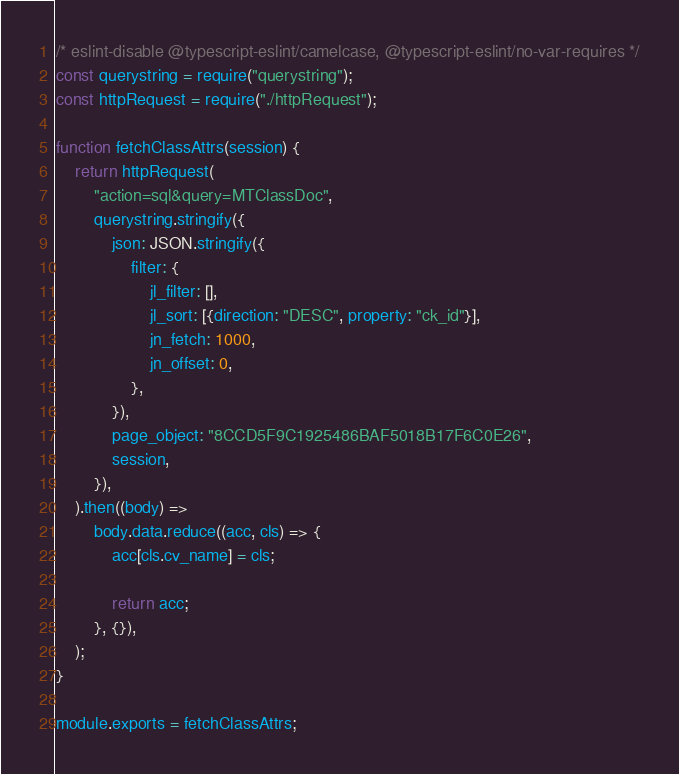Convert code to text. <code><loc_0><loc_0><loc_500><loc_500><_JavaScript_>/* eslint-disable @typescript-eslint/camelcase, @typescript-eslint/no-var-requires */
const querystring = require("querystring");
const httpRequest = require("./httpRequest");

function fetchClassAttrs(session) {
    return httpRequest(
        "action=sql&query=MTClassDoc",
        querystring.stringify({
            json: JSON.stringify({
                filter: {
                    jl_filter: [],
                    jl_sort: [{direction: "DESC", property: "ck_id"}],
                    jn_fetch: 1000,
                    jn_offset: 0,
                },
            }),
            page_object: "8CCD5F9C1925486BAF5018B17F6C0E26",
            session,
        }),
    ).then((body) =>
        body.data.reduce((acc, cls) => {
            acc[cls.cv_name] = cls;

            return acc;
        }, {}),
    );
}

module.exports = fetchClassAttrs;
</code> 